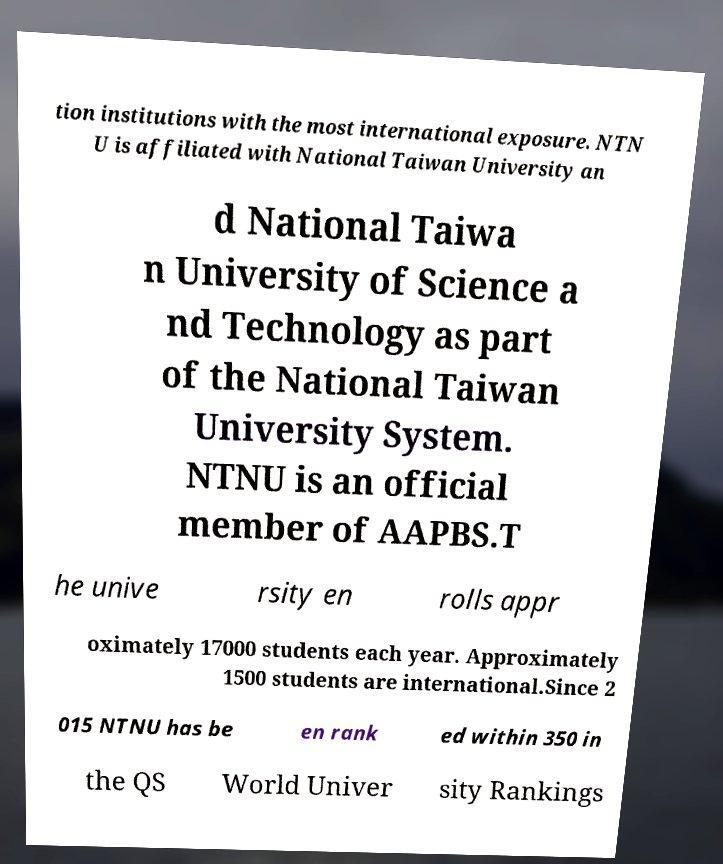Please identify and transcribe the text found in this image. tion institutions with the most international exposure. NTN U is affiliated with National Taiwan University an d National Taiwa n University of Science a nd Technology as part of the National Taiwan University System. NTNU is an official member of AAPBS.T he unive rsity en rolls appr oximately 17000 students each year. Approximately 1500 students are international.Since 2 015 NTNU has be en rank ed within 350 in the QS World Univer sity Rankings 